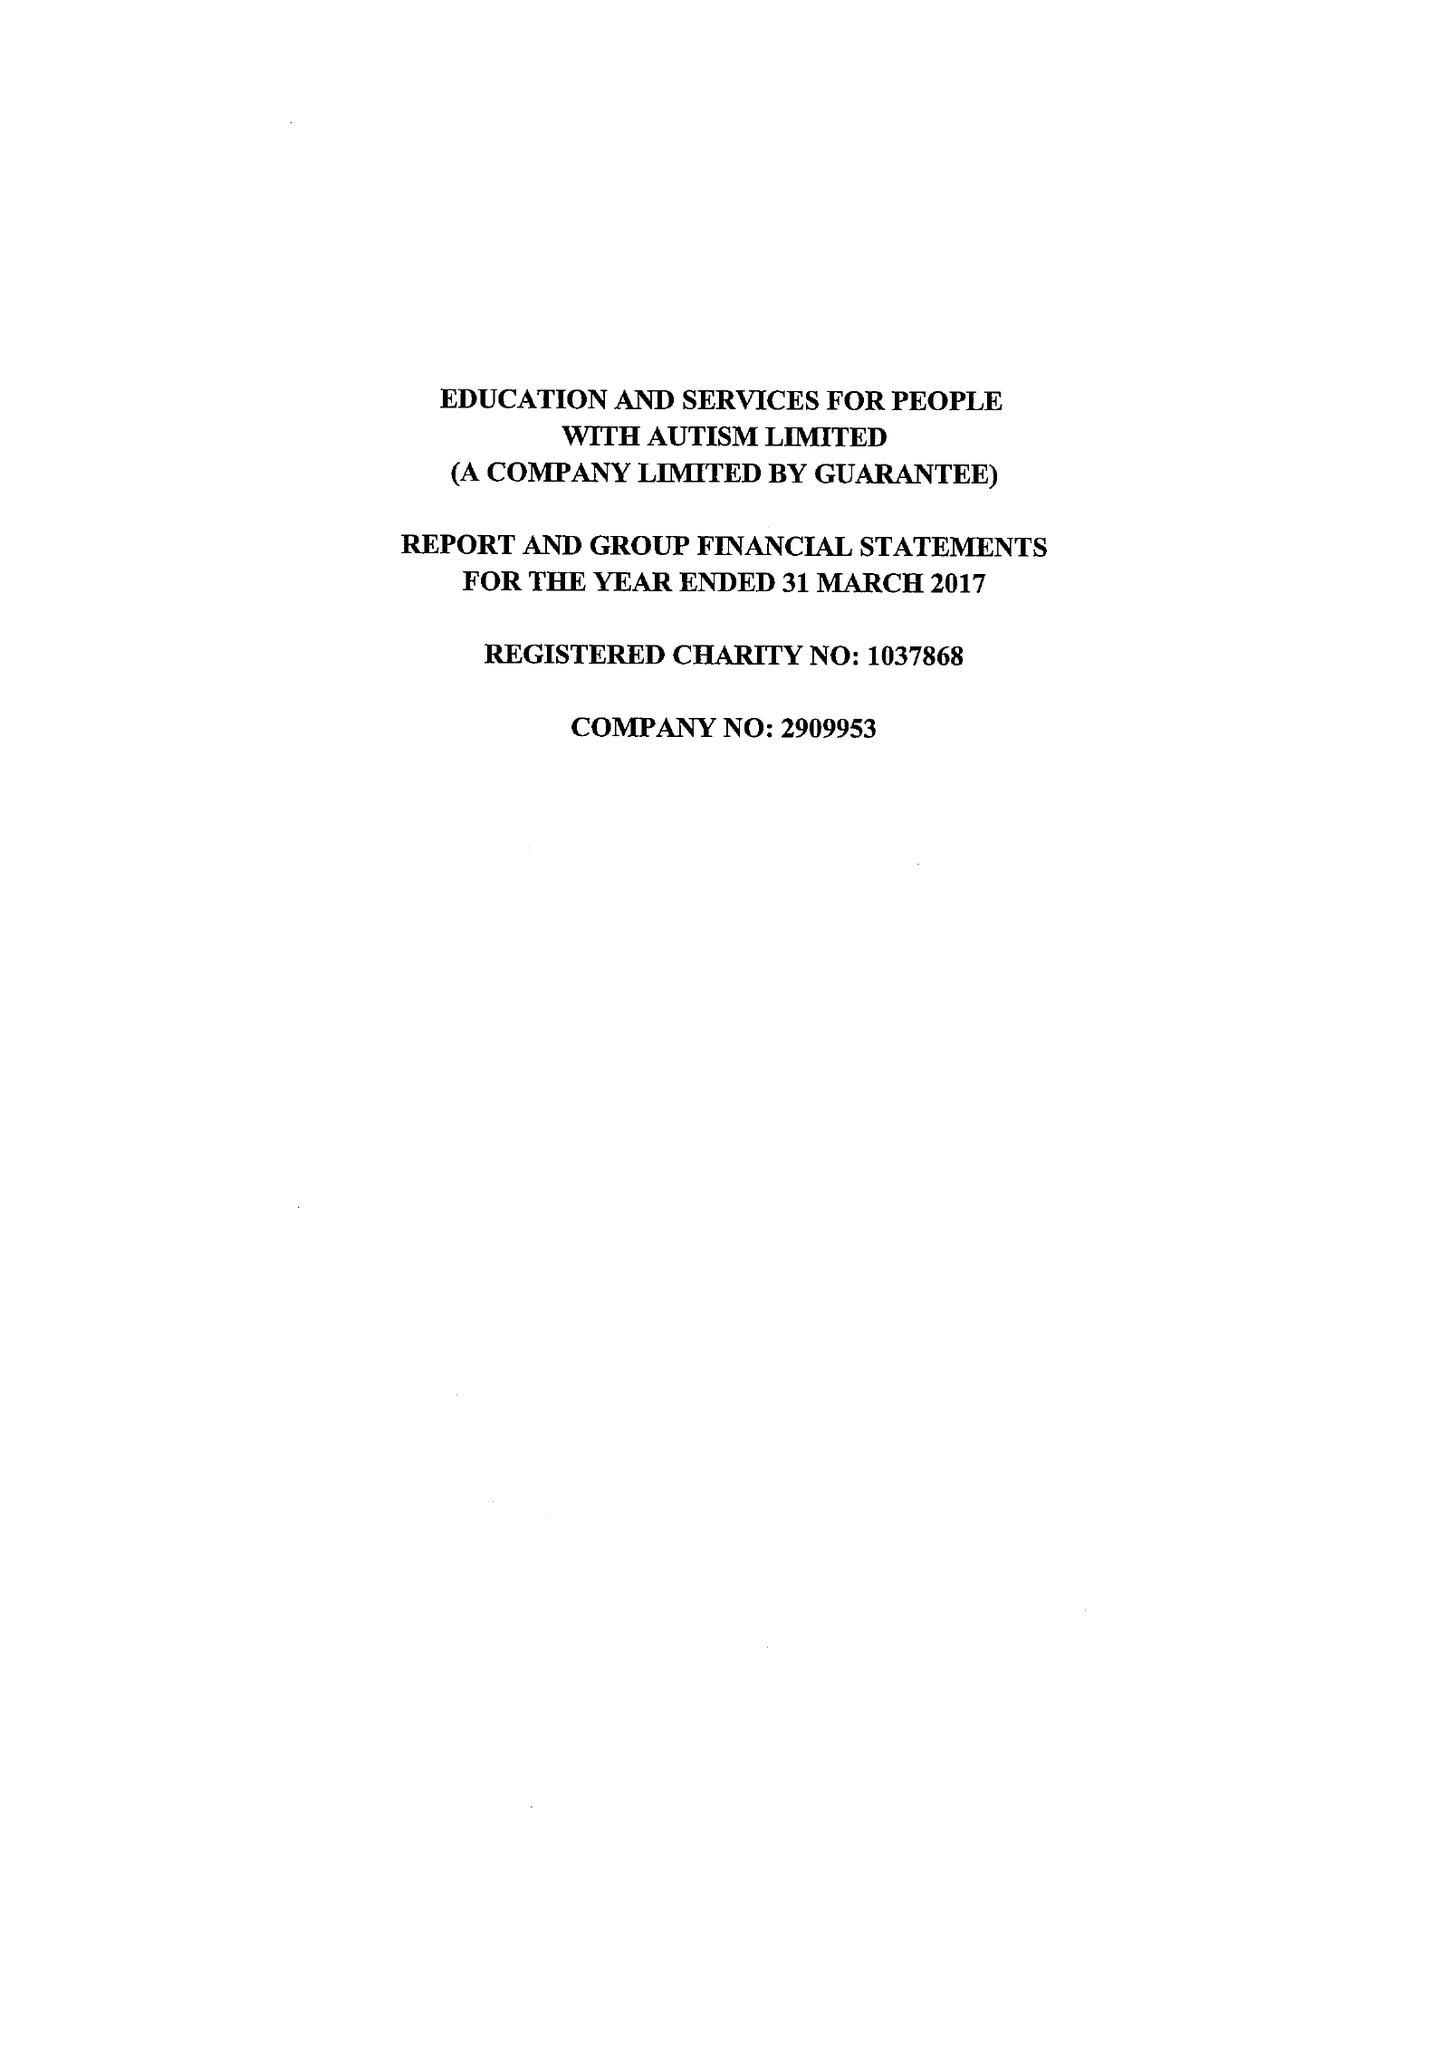What is the value for the address__post_town?
Answer the question using a single word or phrase. SUNDERLAND 